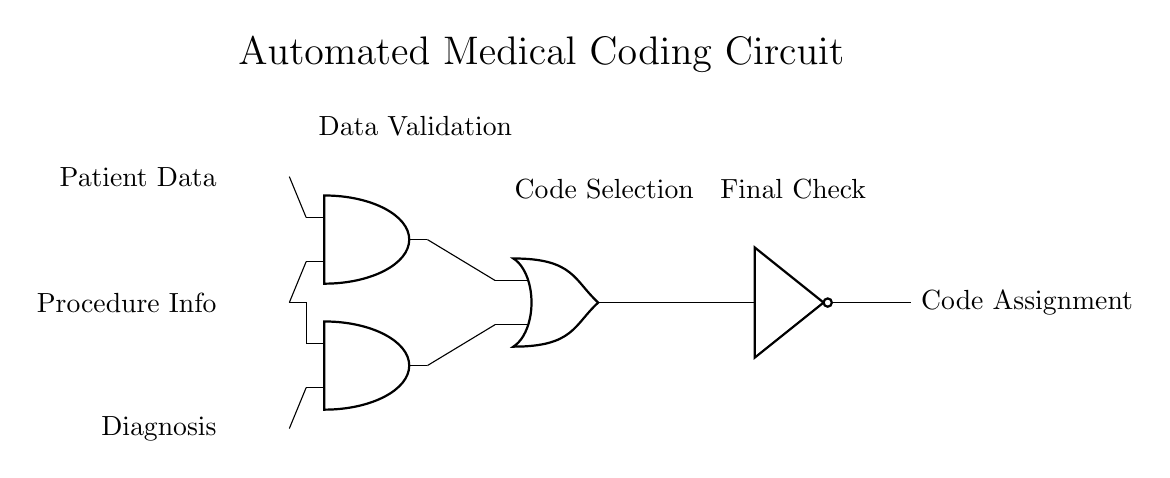What are the inputs of the circuit? The circuit has three inputs: Patient Data, Procedure Info, and Diagnosis. These are indicated by the labels on the left side of the diagram.
Answer: Patient Data, Procedure Info, Diagnosis How many logic gates are present in the circuit? The circuit contains four logic gates: two AND gates, one OR gate, and one NOT gate. This can be counted from the symbols in the diagram.
Answer: Four What is the output of the circuit? The output of the circuit is Code Assignment, which is indicated by the label on the right side stemming from the NOT gate.
Answer: Code Assignment What is the function of the OR gate in this circuit? The OR gate combines the outputs of the two AND gates, allowing for code selection based on the results from data validation and procedure information.
Answer: Combines outputs Why is the NOT gate used in the circuit? The NOT gate inverts the output from the OR gate, providing a final check which may be used to determine whether the coding is valid or needs adjustment, based on the logic of the previous gates.
Answer: To invert output Which gate performs the initial data validation? The first AND gate performs the initial data validation by taking Patient Data and Procedure Info as inputs to confirm that both conditions are met.
Answer: AND gate What is the relationship between the second AND gate and Diagnosis? The second AND gate requires the output from the Procedure Info along with the Diagnosis input, indicating that both must satisfy certain conditions for the output to be true, contributing to the overall decision in coding.
Answer: Requires Diagnosis 